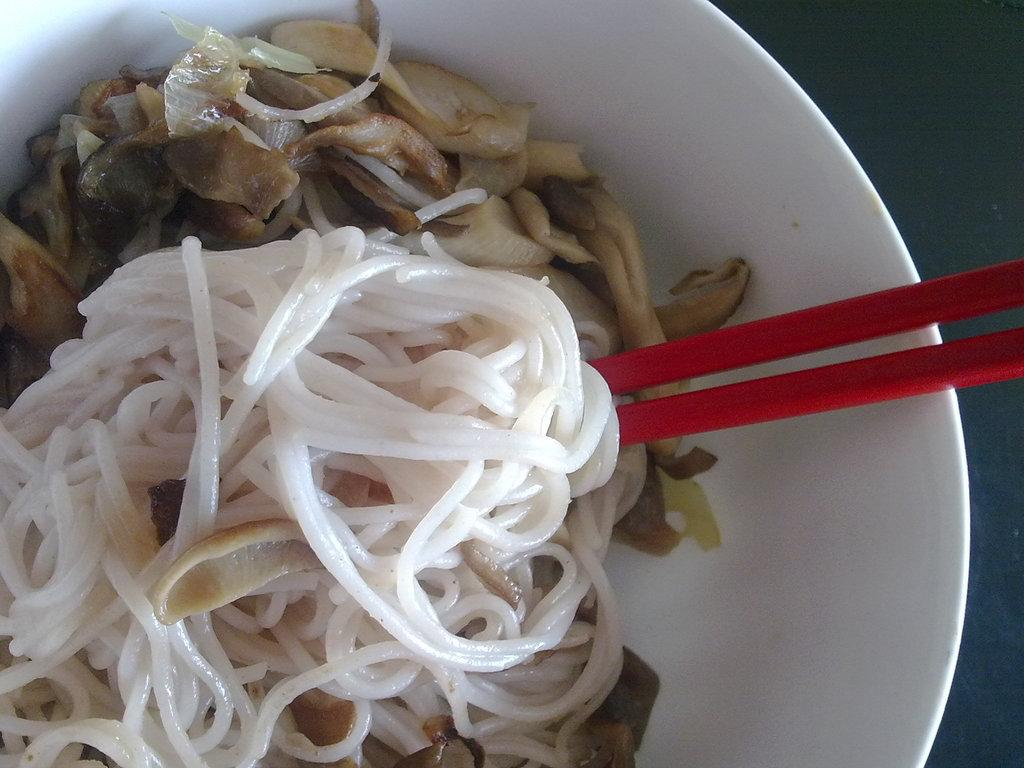What is in the bowl that is visible in the image? There are food items in a bowl in the image. What utensil is present in the image? Chopsticks are visible in the image. What holiday is being celebrated in the image? There is no indication of a holiday being celebrated in the image. How many people are present in the image? The number of people cannot be determined from the image, as only the bowl and chopsticks are visible. 